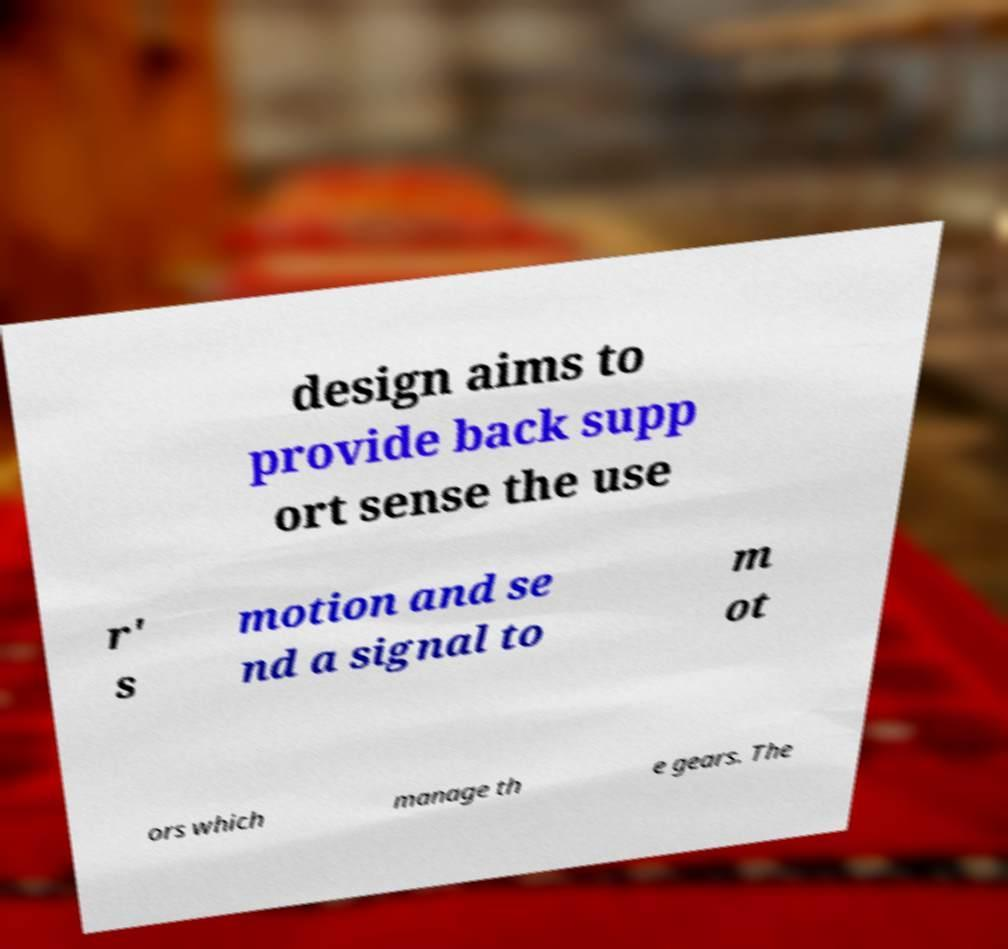Can you accurately transcribe the text from the provided image for me? design aims to provide back supp ort sense the use r' s motion and se nd a signal to m ot ors which manage th e gears. The 